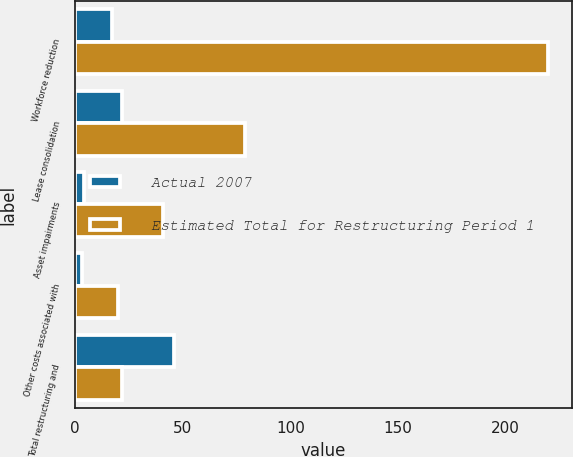<chart> <loc_0><loc_0><loc_500><loc_500><stacked_bar_chart><ecel><fcel>Workforce reduction<fcel>Lease consolidation<fcel>Asset impairments<fcel>Other costs associated with<fcel>Total restructuring and<nl><fcel>Actual 2007<fcel>17<fcel>22<fcel>4<fcel>3<fcel>46<nl><fcel>Estimated Total for Restructuring Period 1<fcel>220<fcel>79<fcel>41<fcel>20<fcel>22<nl></chart> 